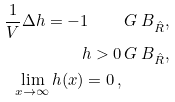Convert formula to latex. <formula><loc_0><loc_0><loc_500><loc_500>\frac { 1 } { V } \Delta h = - 1 \quad & \, G \ B _ { \hat { R } } , \\ h > 0 & \, G \ B _ { \hat { R } } , \\ \lim _ { x \to \infty } h ( x ) = 0 \, , &</formula> 